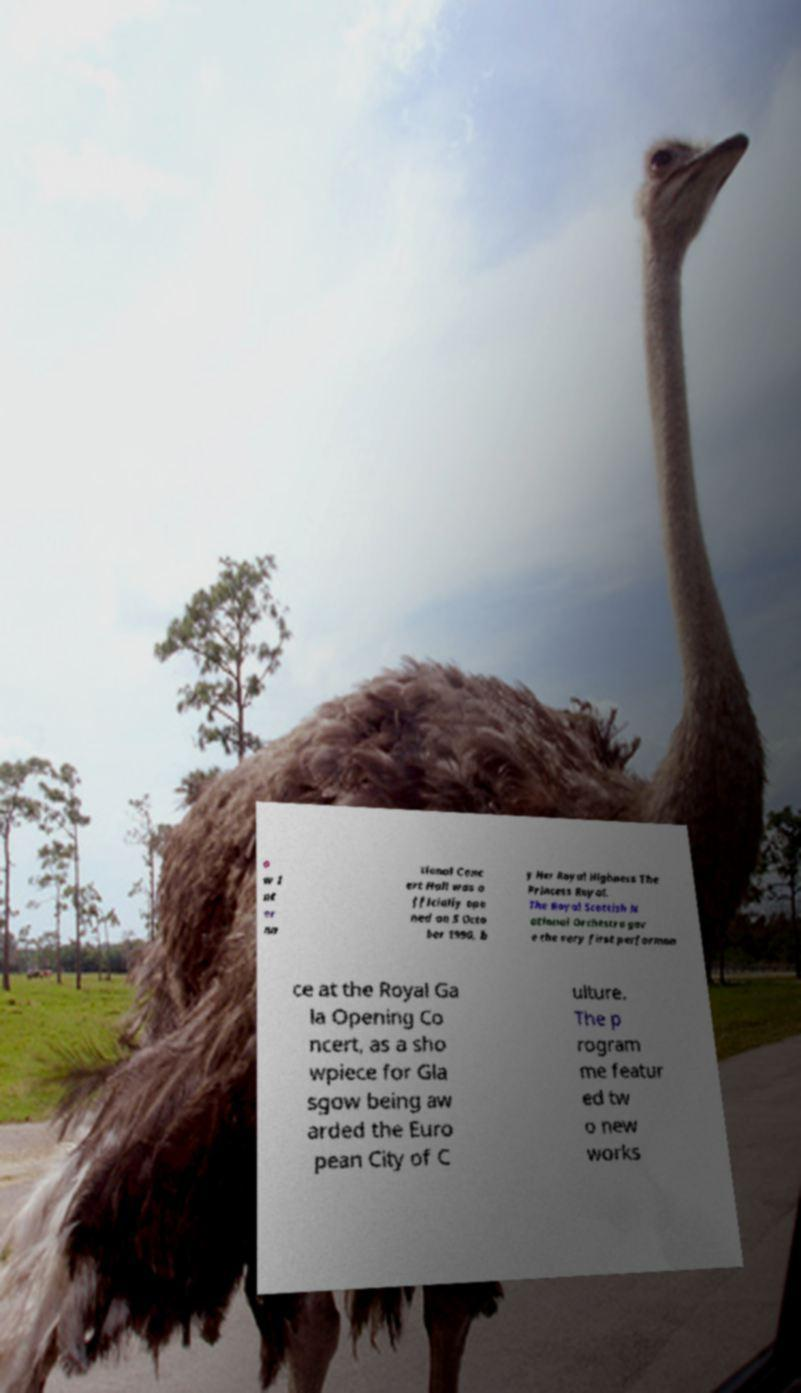Could you assist in decoding the text presented in this image and type it out clearly? o w I nt er na tional Conc ert Hall was o fficially ope ned on 5 Octo ber 1990, b y Her Royal Highness The Princess Royal. The Royal Scottish N ational Orchestra gav e the very first performan ce at the Royal Ga la Opening Co ncert, as a sho wpiece for Gla sgow being aw arded the Euro pean City of C ulture. The p rogram me featur ed tw o new works 